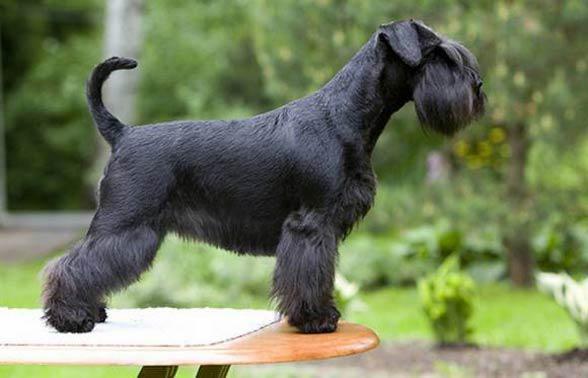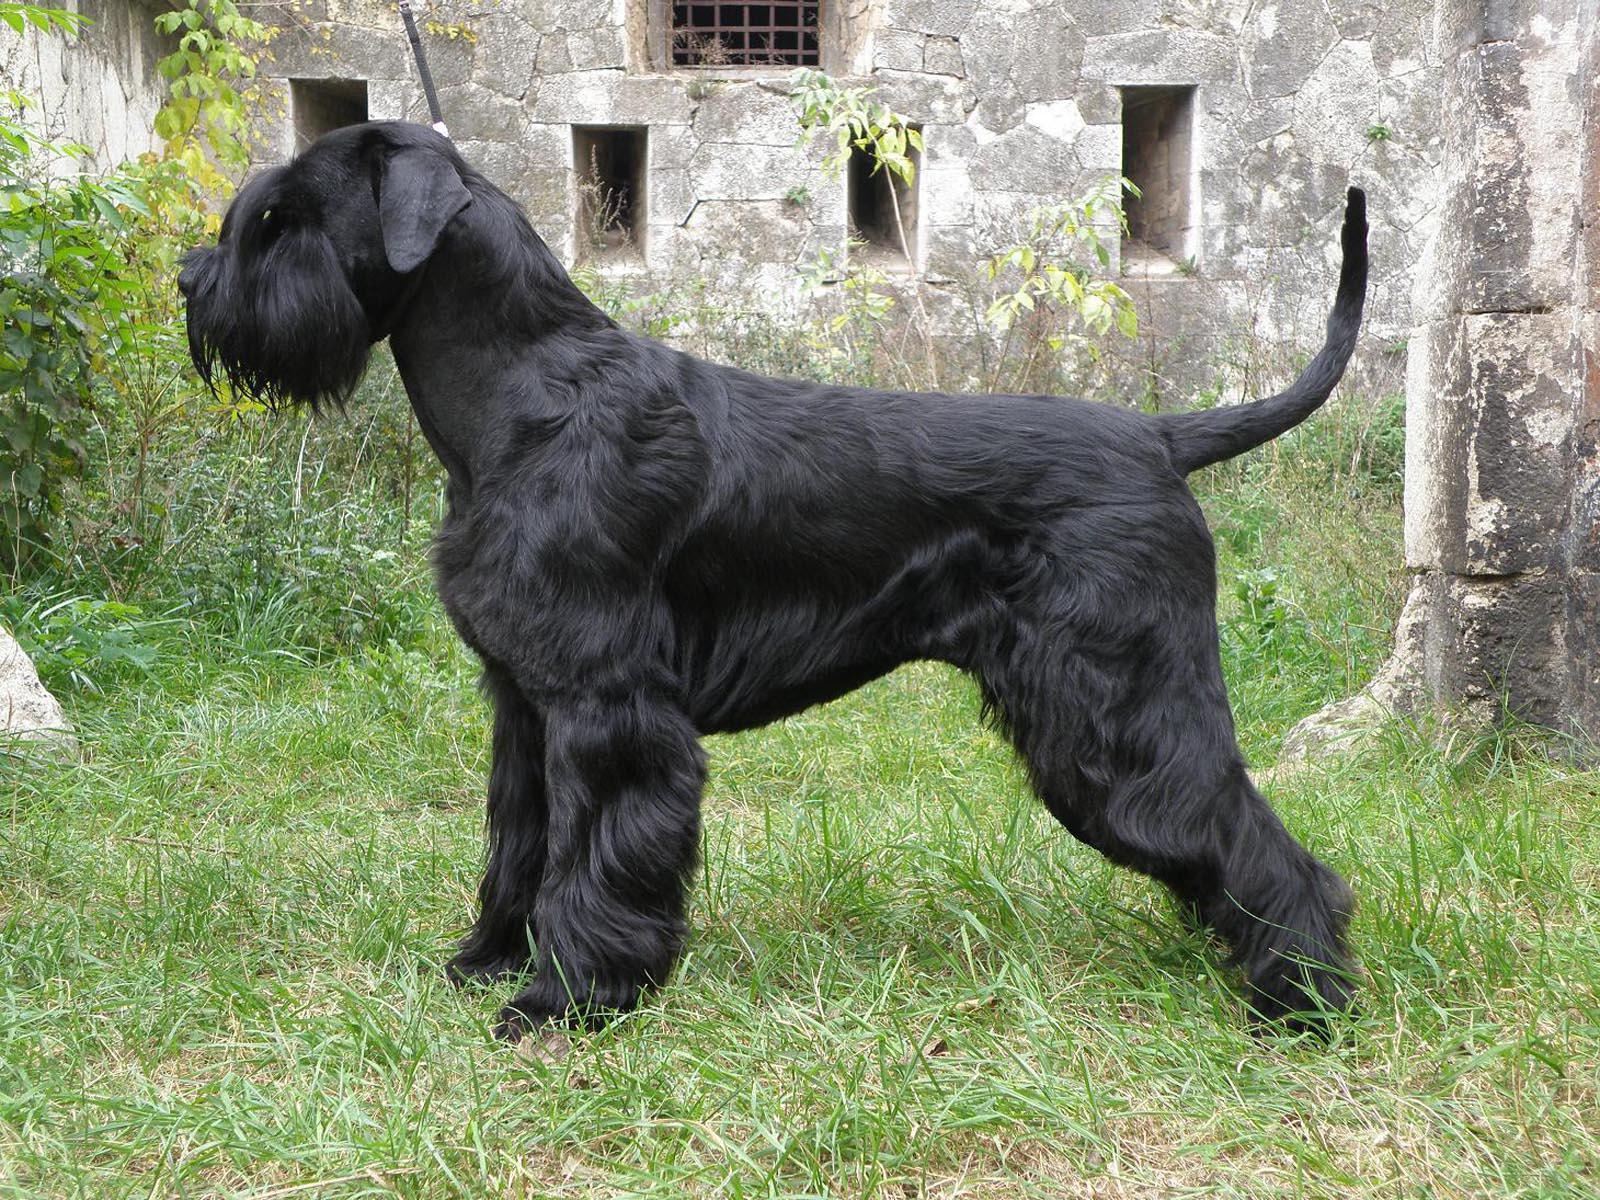The first image is the image on the left, the second image is the image on the right. Evaluate the accuracy of this statement regarding the images: "there is a black dog in the image on the right". Is it true? Answer yes or no. Yes. The first image is the image on the left, the second image is the image on the right. Examine the images to the left and right. Is the description "There is an all black dog standing and facing to the right in one of the images." accurate? Answer yes or no. Yes. 